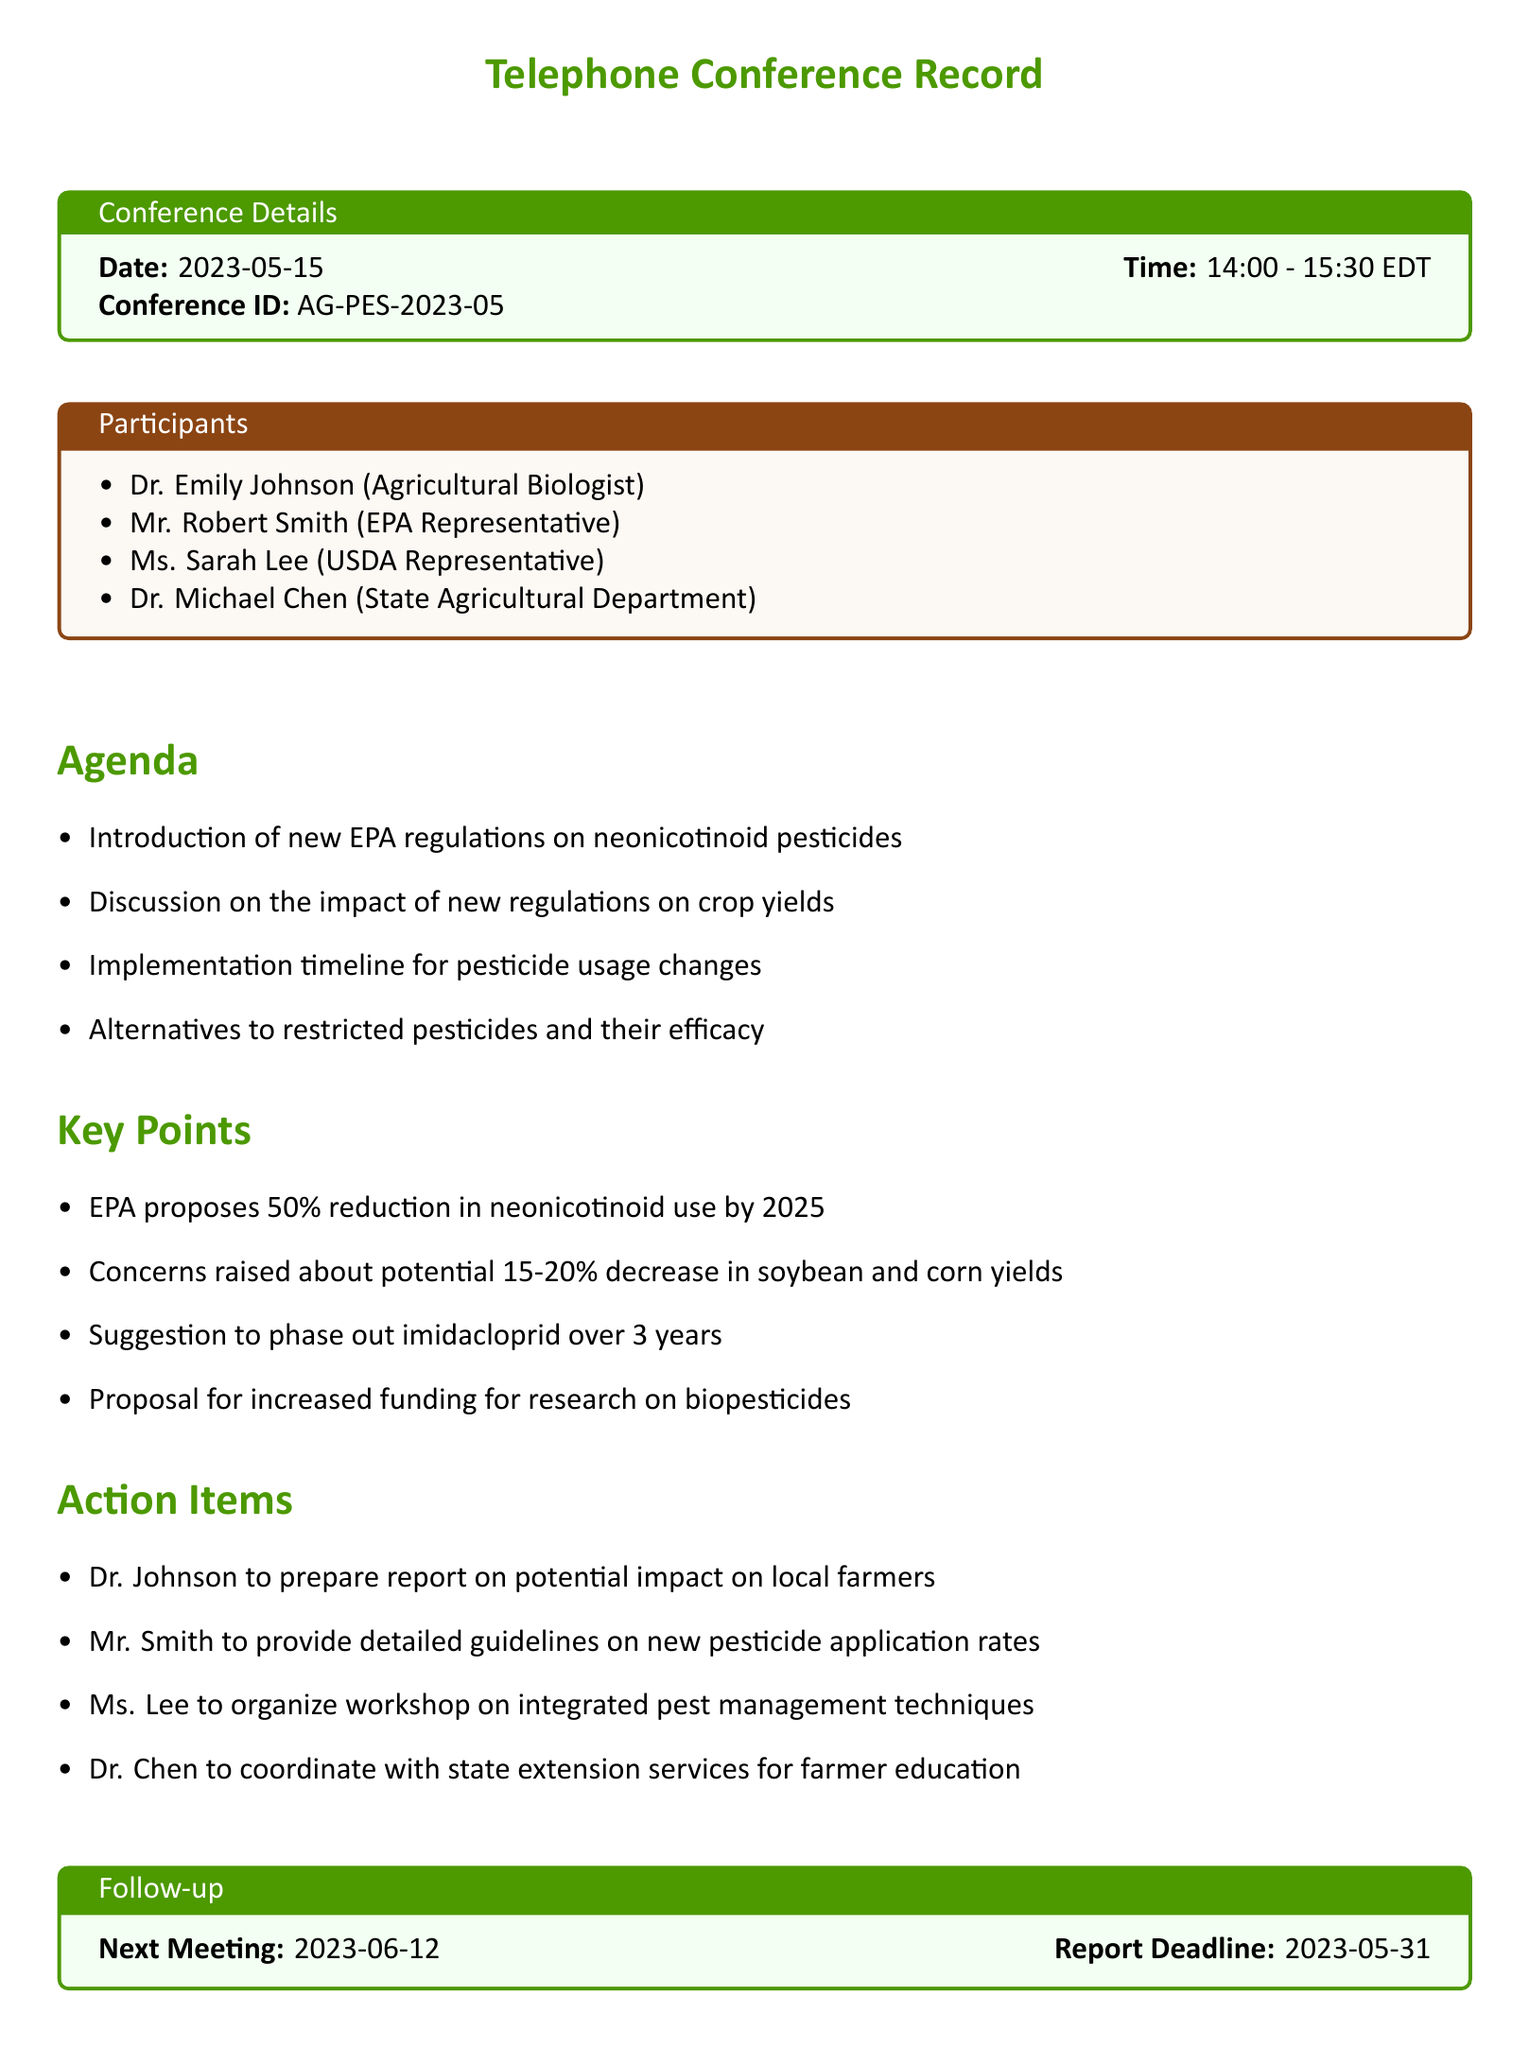What is the date of the conference? The date is mentioned in the conference details section of the document.
Answer: 2023-05-15 Who is the USDA representative? The participants section lists the individuals and their affiliations.
Answer: Ms. Sarah Lee What is the main agenda item regarding pesticides? The agenda section outlines the topics discussed during the conference.
Answer: Introduction of new EPA regulations on neonicotinoid pesticides What is the proposed percentage reduction in neonicotinoid use? The key points outline the proposals made during the conference.
Answer: 50% What is the deadline for the report from Dr. Johnson? The follow-up section specifies the report deadline discussed in the action items.
Answer: 2023-05-31 What is the implementation timeline for pesticide usage changes? The agenda mentions a specific timeline discussed for regulatory changes.
Answer: Not specified in the document What action is Ms. Lee responsible for? The action items detail the responsibilities assigned to each participant.
Answer: Organize workshop on integrated pest management techniques When is the next meeting scheduled? The follow-up section includes the date for the next meeting.
Answer: 2023-06-12 